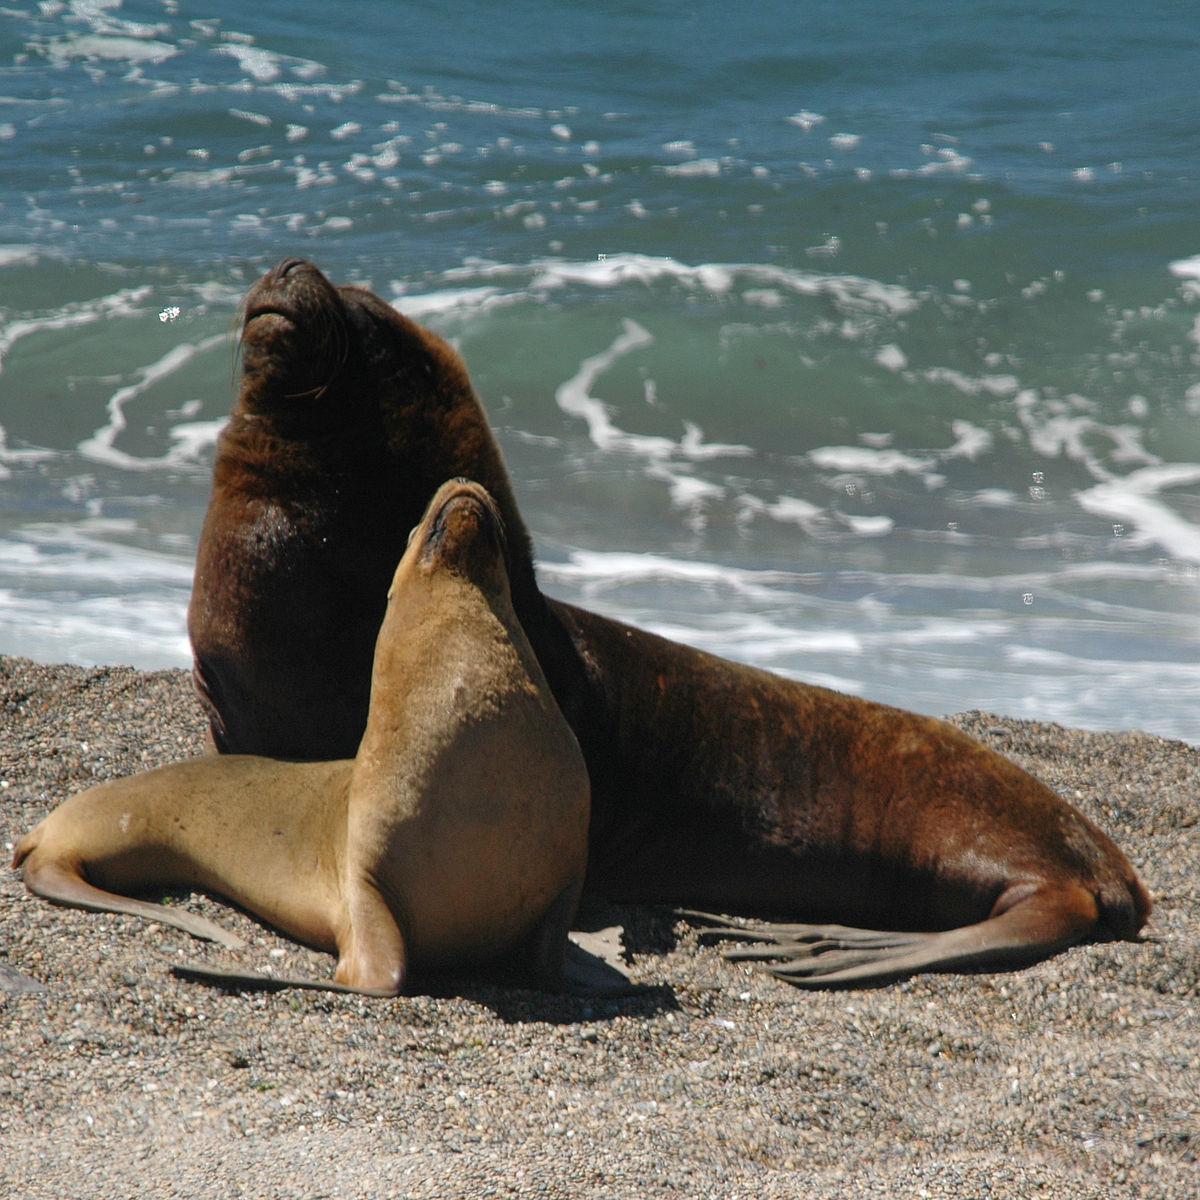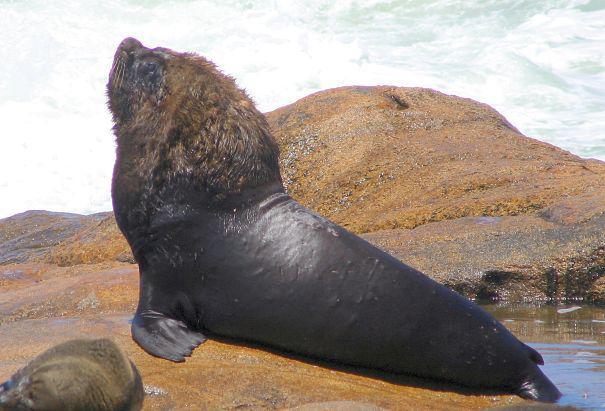The first image is the image on the left, the second image is the image on the right. Examine the images to the left and right. Is the description "Left image shows two seals with upraised heads, one large and dark, and the other smaller and paler." accurate? Answer yes or no. Yes. 